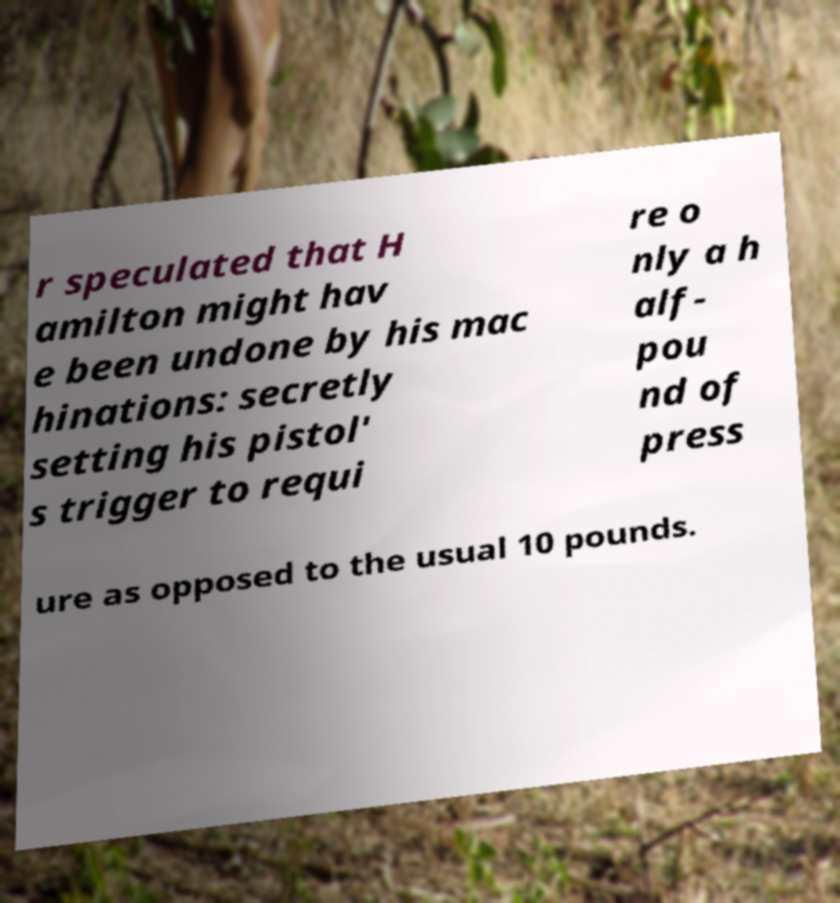Please read and relay the text visible in this image. What does it say? r speculated that H amilton might hav e been undone by his mac hinations: secretly setting his pistol' s trigger to requi re o nly a h alf- pou nd of press ure as opposed to the usual 10 pounds. 